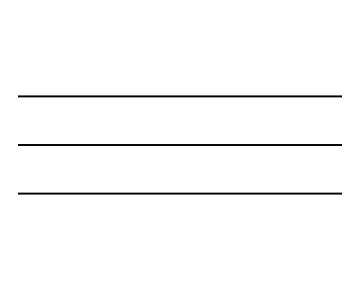What is the molecular formula of this compound? The chemical depicted with the SMILES representation C#C indicates two carbon atoms and does not contain any other elements, so the molecular formula is C2H2.
Answer: C2H2 How many carbon atoms are present in acetylene? The SMILES representation reveals two carbon atoms, which are represented by 'C' in the structure.
Answer: 2 What type of bond connects the carbon atoms in acetylene? The presence of the '#' symbol in the SMILES representation indicates a triple bond connecting the two carbon atoms.
Answer: triple bond What is the hybridization of the carbon atoms in acetylene? Each carbon atom in acetylene is involved in a triple bond, indicating that they both use sp hybridization, which is typical for carbon atoms in such a bonding scenario.
Answer: sp Is acetylene an alkane, alkene, or alkyne? Acetylene features a triple bond between the carbon atoms, which categorizes it as an alkyne, distinct from alkanes (single bonds) and alkenes (double bonds).
Answer: alkyne How many hydrogens are bound to the carbon atoms in acetylene? The molecular formula shows there are two hydrogen atoms bound to the two carbon atoms, derived from the formula C2H2.
Answer: 2 What type of hydrocarbon is acetylene classified as? Acetylene, with its characteristics of containing only carbon and hydrogen and featuring a triple bond, is classified as an unsaturated hydrocarbon.
Answer: unsaturated hydrocarbon 